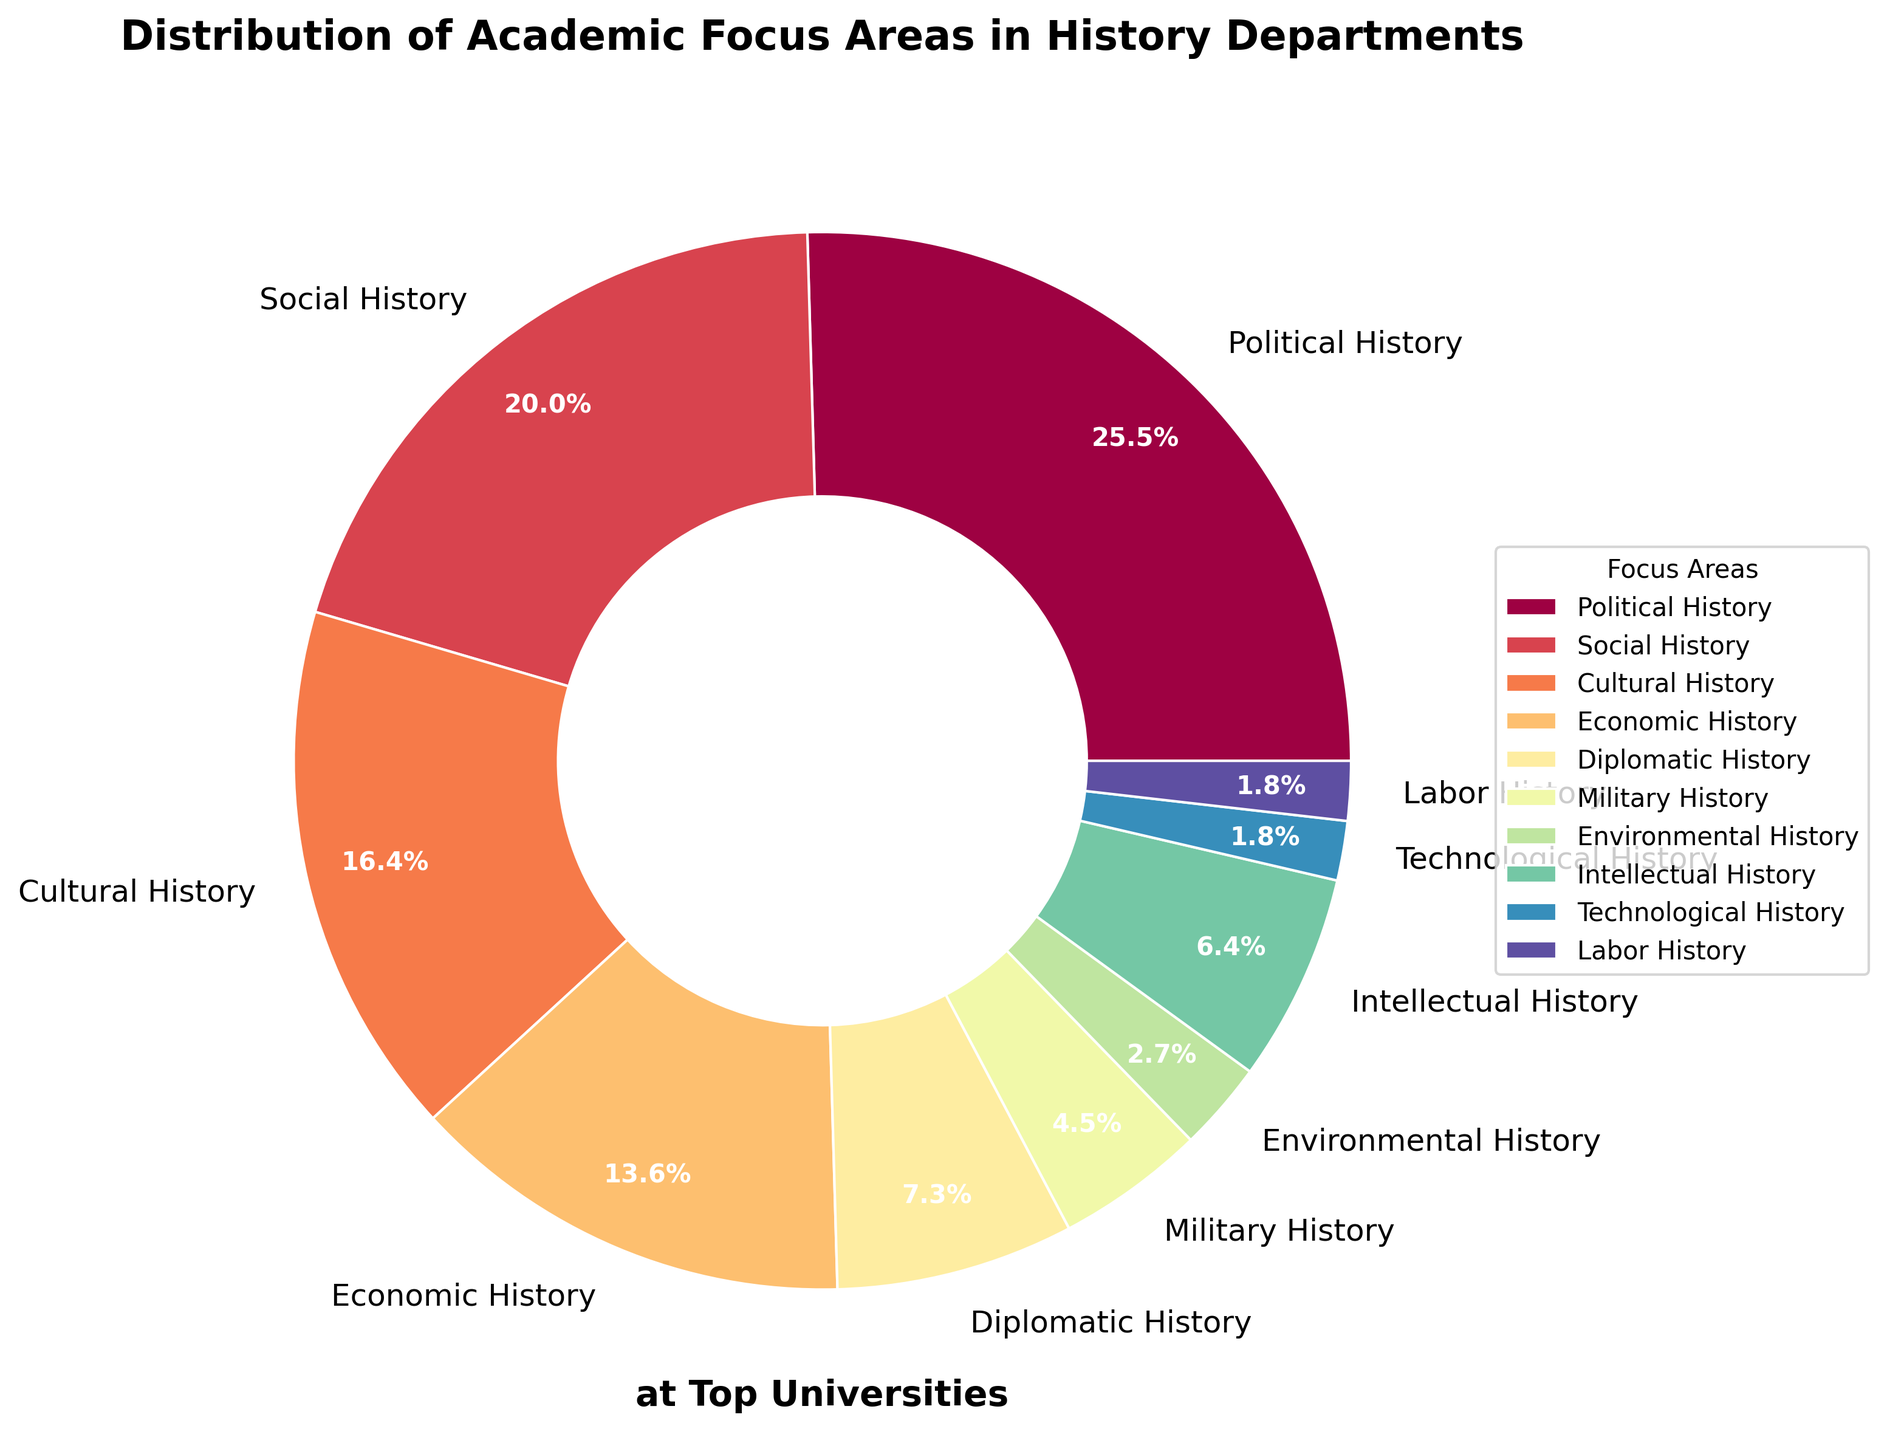What is the largest academic focus area in history departments at top universities? The largest area has the highest percentage in the pie chart. The largest slice represents Political History at 28%.
Answer: Political History Which two academic focus areas together make up exactly 10%? Look for slices whose percentages add up to 10%. Both Technological History (2%) and Labor History (2%) combine with Environmental History (3%) to make a total of 10%.
Answer: Technological History, Labor History, Environmental History What is the difference in percentages between Political History and Diplomatic History? Subtract the percentage of Diplomatic History from Political History. Political History is 28%, and Diplomatic History is 8%, so the difference is 28% - 8% = 20%.
Answer: 20% Which academic focus area is represented by the smallest slice? The smallest slice or segment in the pie chart visually identifies the smallest percentage area. Both Technological History and Labor History are the smallest, each at 2%.
Answer: Technological History, Labor History How many academic focus areas make up less than 10% each? Count the number of slices that represent less than 10% each. These are Diplomatic History (8%), Military History (5%), Environmental History (3%), Intellectual History (7%), Technological History (2%), and Labor History (2%).
Answer: 6 What is the combined percentage of Social History and Economic History? Add the percentages of Social History and Economic History. Social History is 22%, and Economic History is 15%, so combined they are 22% + 15% = 37%.
Answer: 37% Does Social History have a larger percentage than Cultural History? If so, by how much? Compare percentages of Social History (22%) and Cultural History (18%). Subtract Cultural History from Social History, 22% - 18% = 4%.
Answer: Yes, by 4% Which academic focus area lies between Economic History and Diplomatic History in terms of percentage? Identify the slices and their percentages. Economic History is at 15%, Diplomatic History is at 8%. The area lying in between percentages is Intellectual History at 7%.
Answer: Intellectual History What is the combined total percentage of Military History, Environmental History, and Technological History? Sum the percentages of Military History (5%), Environmental History (3%), and Technological History (2%), total is 5% + 3% + 2% = 10%.
Answer: 10% If you combine the percentages of the three smallest focus areas, what percentage of the total do they represent? Combine percentages of the smallest areas: Technological History (2%), Labor History (2%), and Environmental History (3%). Total is 2% + 2% + 3% = 7%.
Answer: 7% 